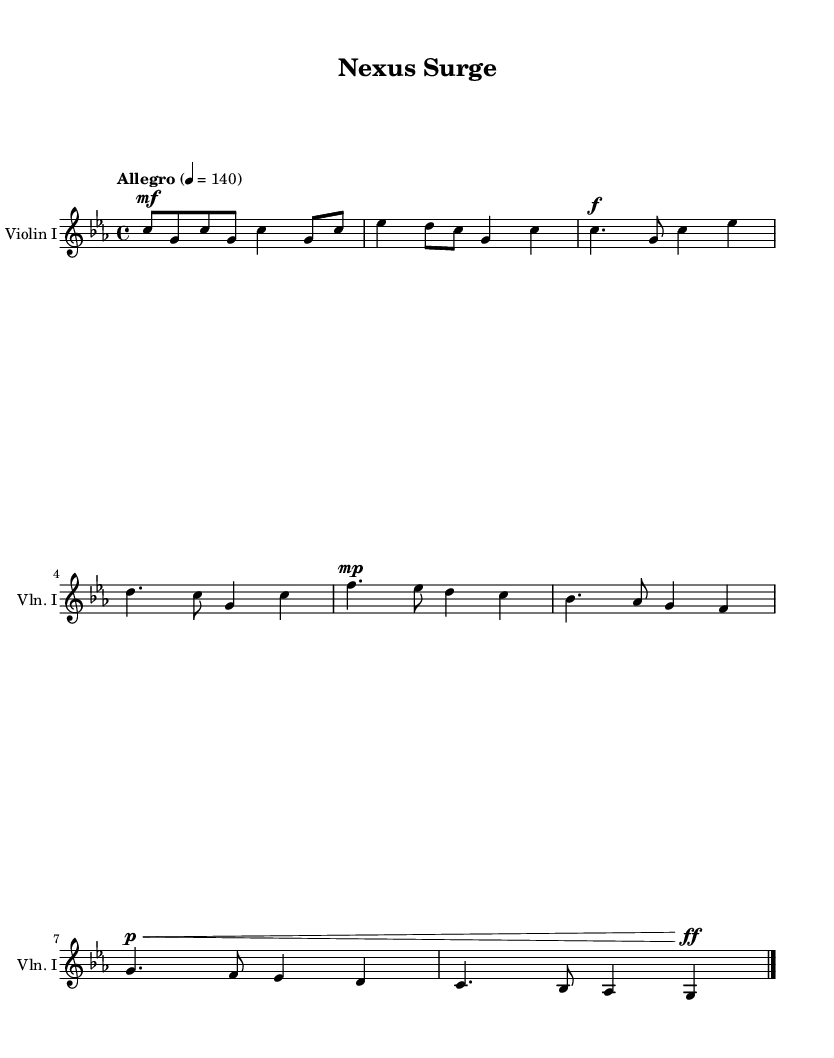What is the key signature of this music? The key signature is C minor, which has three flats (B♭, E♭, and A♭). This is indicated at the beginning of the staff, where the flats are shown alongside the clef.
Answer: C minor What is the time signature of this piece? The time signature is 4/4, which means there are four beats in each measure and a quarter note gets one beat. This is explicitly shown at the beginning of the score.
Answer: 4/4 What is the tempo marking for this score? The tempo marking is "Allegro," which indicates a fast pace, and the number "4 = 140" indicates that the quarter note should be played at 140 beats per minute. This is found in the tempo indication at the beginning.
Answer: Allegro How many measures are in the first section of the music? The first section of the music consists of 8 measures, which can be counted by looking at the notation and dividing the music into measures marked by vertical bar lines.
Answer: 8 What dynamic marking is indicated for the last measure? The last measure has a dynamic marking of "ff", which stands for fortissimo, indicating that this section should be played very loudly. This marking is shown above the notes in the last measure.
Answer: ff How does the melody primarily move in this piece? The melody primarily moves by step, with small intervals between successive notes, allowing for a smooth and flowing sound typical of orchestral music in film soundtracks. This can be assessed by observing the distance between consecutive notes in the staff.
Answer: By step What is the instrumentation indicated for this score? The instrumentation indicated is "Violin I," which is specified at the beginning of the staff, denoting that this part is written for the first violin. This can be identified by looking at the name above the staff.
Answer: Violin I 